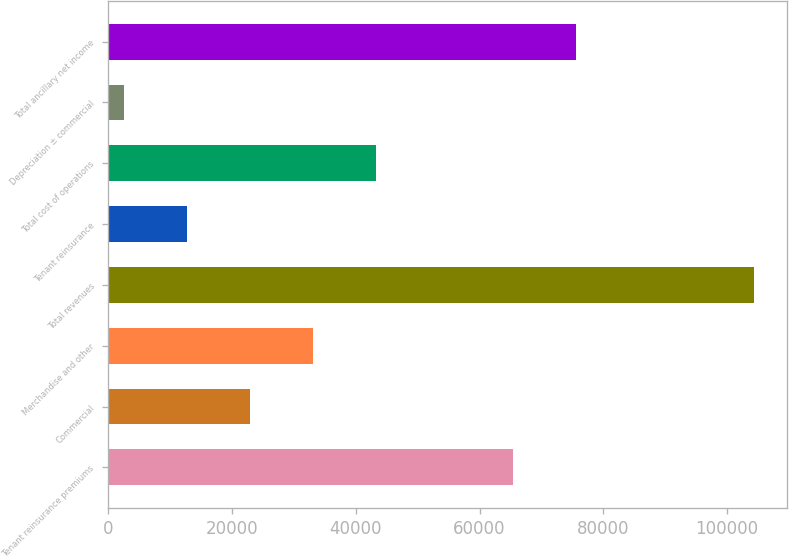Convert chart. <chart><loc_0><loc_0><loc_500><loc_500><bar_chart><fcel>Tenant reinsurance premiums<fcel>Commercial<fcel>Merchandise and other<fcel>Total revenues<fcel>Tenant reinsurance<fcel>Total cost of operations<fcel>Depreciation ± commercial<fcel>Total ancillary net income<nl><fcel>65484<fcel>22972.2<fcel>33148.3<fcel>104381<fcel>12796.1<fcel>43324.4<fcel>2620<fcel>75660.1<nl></chart> 